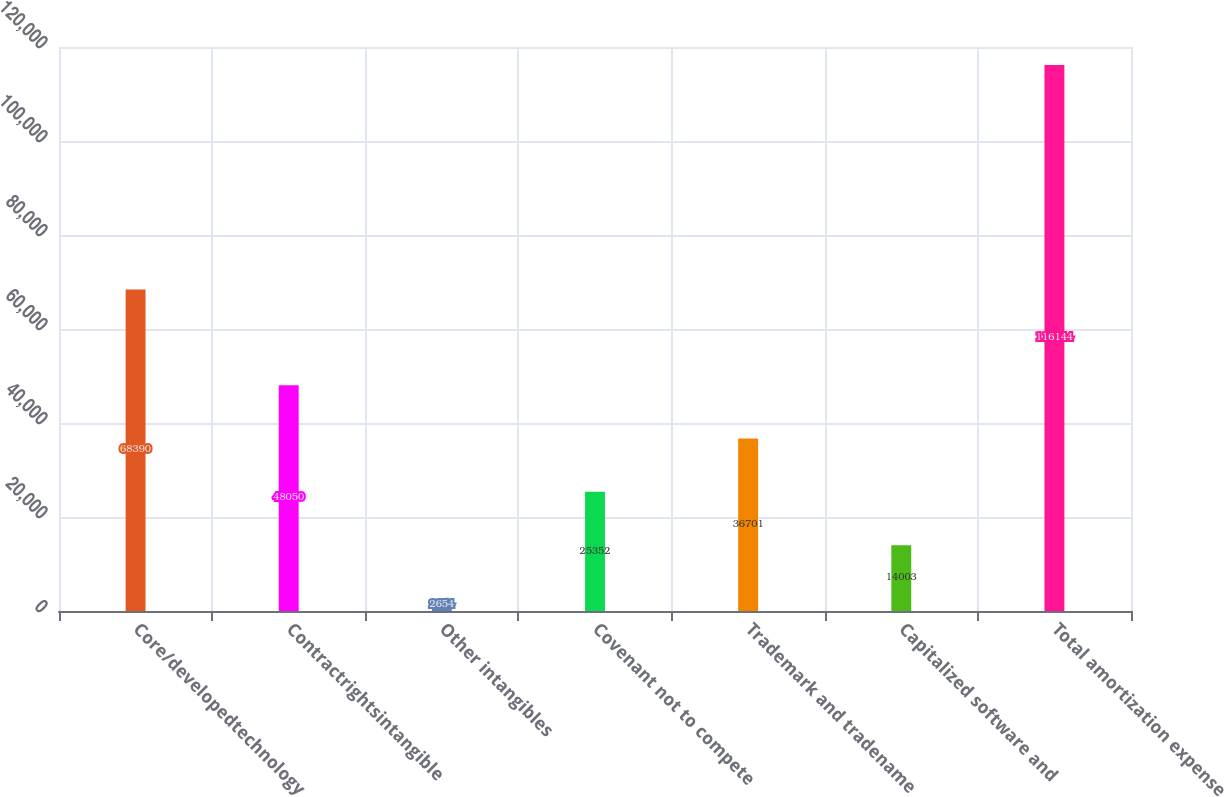Convert chart. <chart><loc_0><loc_0><loc_500><loc_500><bar_chart><fcel>Core/developedtechnology<fcel>Contractrightsintangible<fcel>Other intangibles<fcel>Covenant not to compete<fcel>Trademark and tradename<fcel>Capitalized software and<fcel>Total amortization expense<nl><fcel>68390<fcel>48050<fcel>2654<fcel>25352<fcel>36701<fcel>14003<fcel>116144<nl></chart> 